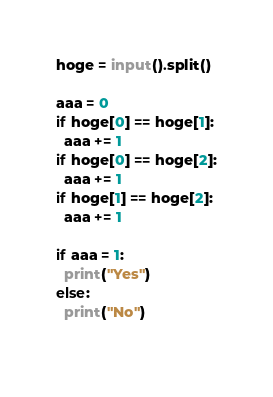Convert code to text. <code><loc_0><loc_0><loc_500><loc_500><_Python_>hoge = input().split()
 
aaa = 0  
if hoge[0] == hoge[1]:
  aaa += 1
if hoge[0] == hoge[2]:
  aaa += 1
if hoge[1] == hoge[2]:
  aaa += 1    

if aaa = 1:
  print("Yes")
else:
  print("No")
	</code> 